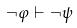Convert formula to latex. <formula><loc_0><loc_0><loc_500><loc_500>\neg \varphi \vdash \neg \psi</formula> 